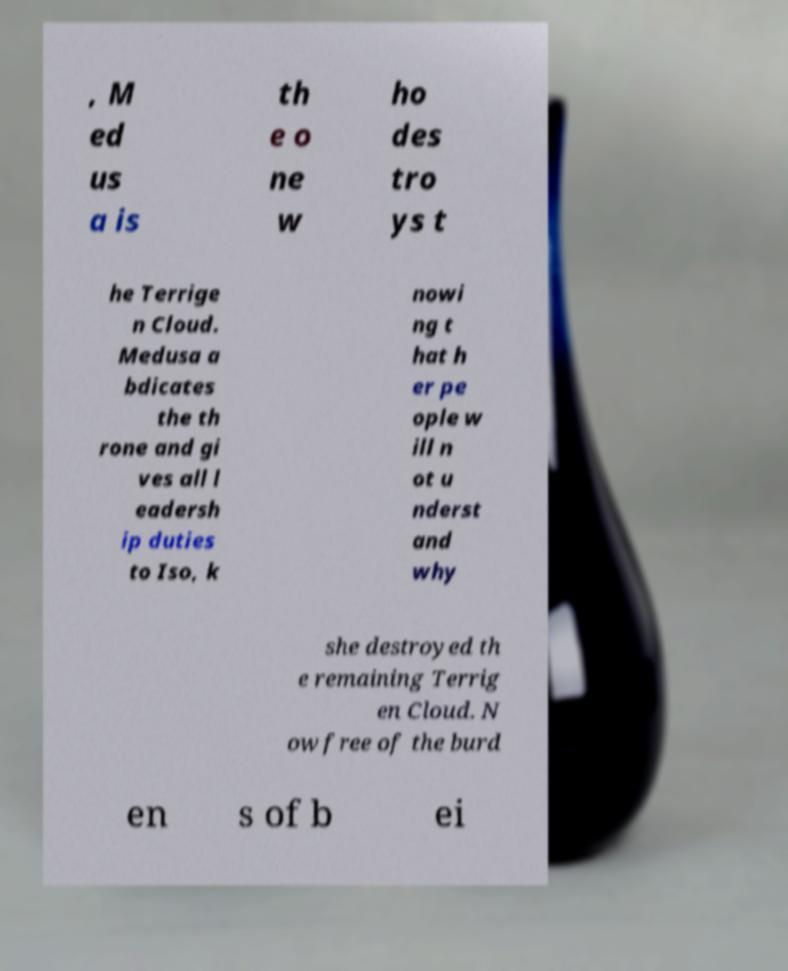I need the written content from this picture converted into text. Can you do that? , M ed us a is th e o ne w ho des tro ys t he Terrige n Cloud. Medusa a bdicates the th rone and gi ves all l eadersh ip duties to Iso, k nowi ng t hat h er pe ople w ill n ot u nderst and why she destroyed th e remaining Terrig en Cloud. N ow free of the burd en s of b ei 